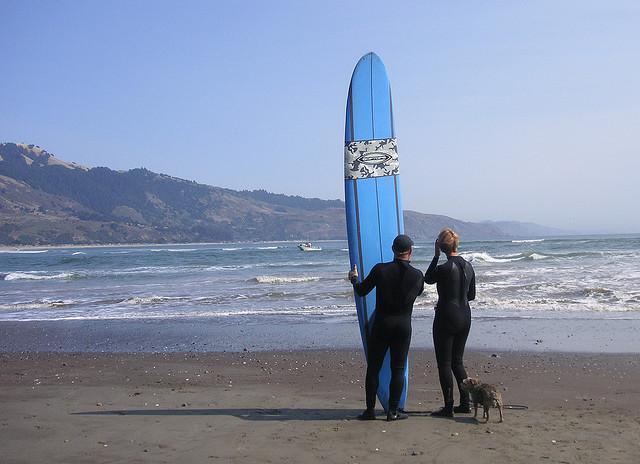How many surfboards are behind the man?
Give a very brief answer. 1. How many people are there?
Give a very brief answer. 2. How many zebras are on the road?
Give a very brief answer. 0. 